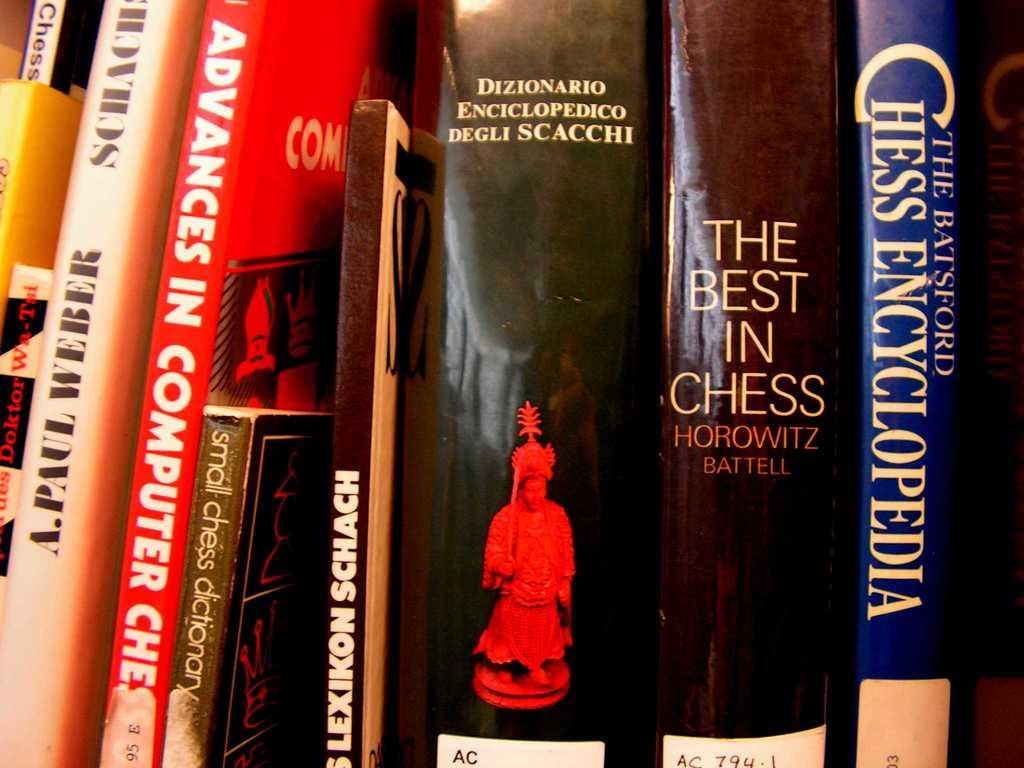Who wrote the book,"the best in chess"?
Give a very brief answer. Horowitz battell. 